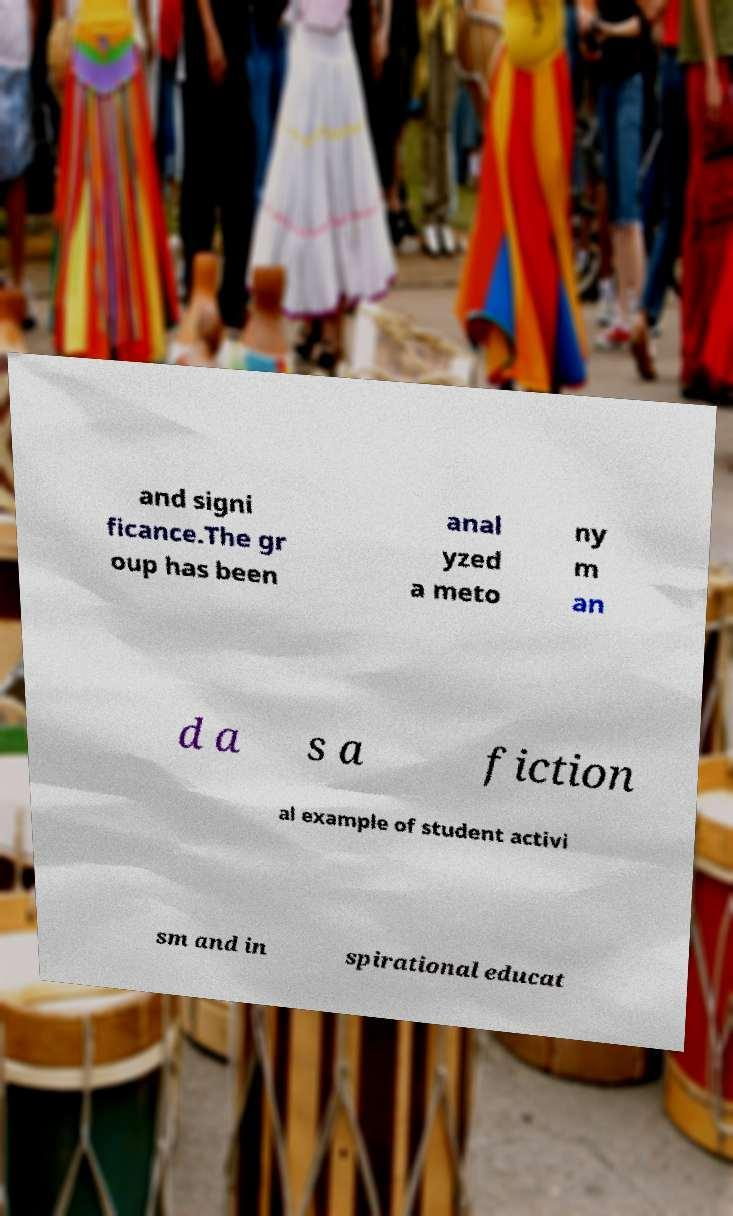Can you read and provide the text displayed in the image?This photo seems to have some interesting text. Can you extract and type it out for me? and signi ficance.The gr oup has been anal yzed a meto ny m an d a s a fiction al example of student activi sm and in spirational educat 